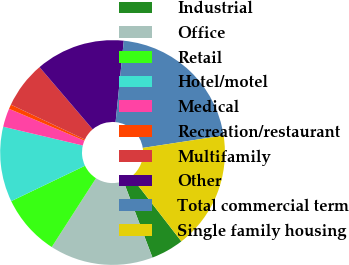<chart> <loc_0><loc_0><loc_500><loc_500><pie_chart><fcel>Industrial<fcel>Office<fcel>Retail<fcel>Hotel/motel<fcel>Medical<fcel>Recreation/restaurant<fcel>Multifamily<fcel>Other<fcel>Total commercial term<fcel>Single family housing<nl><fcel>4.71%<fcel>14.88%<fcel>8.78%<fcel>10.81%<fcel>2.67%<fcel>0.64%<fcel>6.74%<fcel>12.85%<fcel>20.99%<fcel>16.92%<nl></chart> 